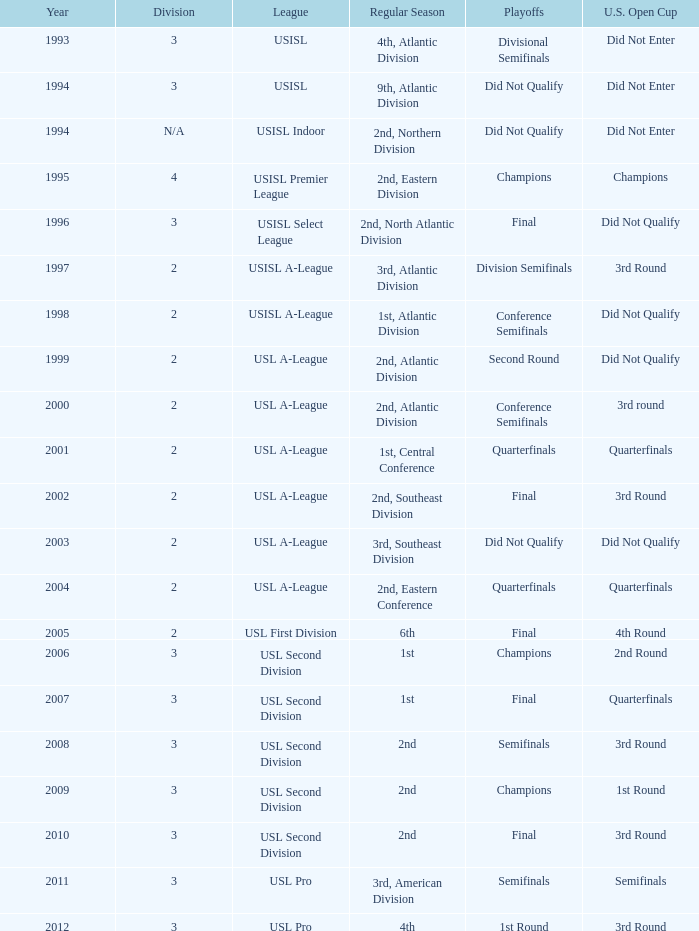How many division  did not qualify for u.s. open cup in 2003 2.0. 